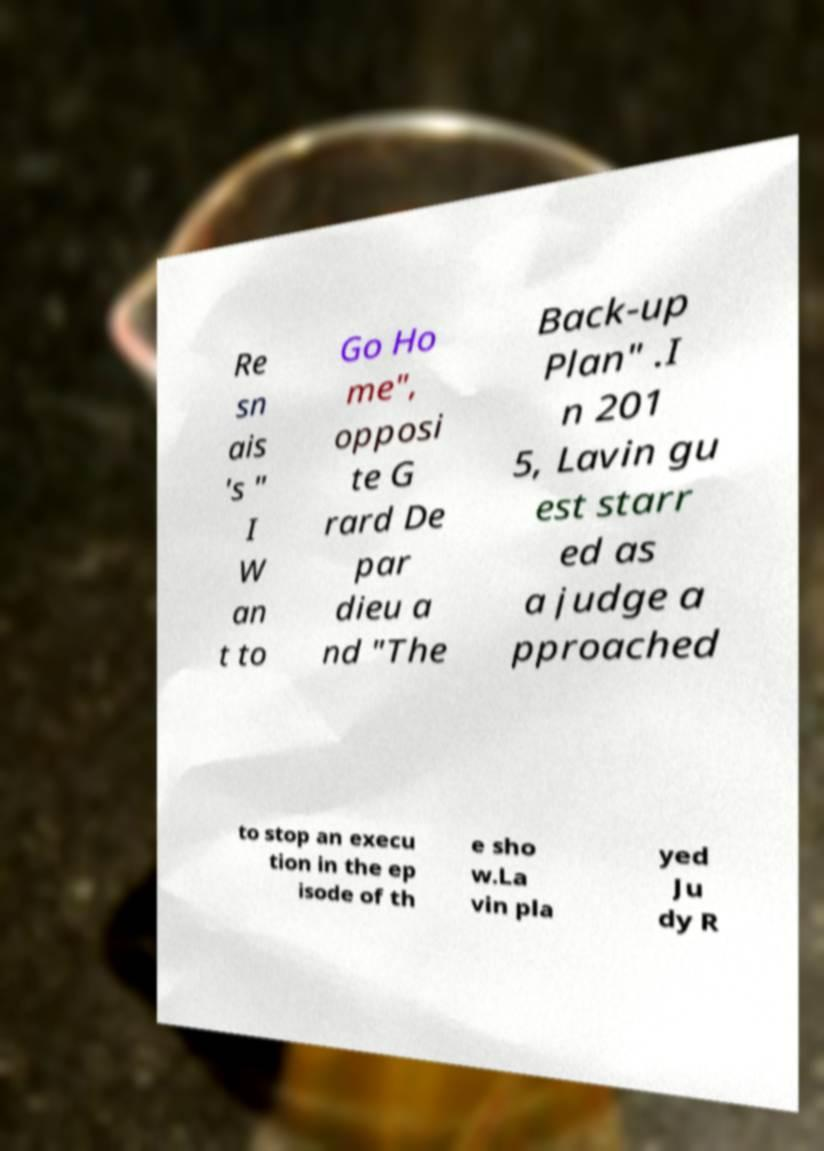What messages or text are displayed in this image? I need them in a readable, typed format. Re sn ais 's " I W an t to Go Ho me", opposi te G rard De par dieu a nd "The Back-up Plan" .I n 201 5, Lavin gu est starr ed as a judge a pproached to stop an execu tion in the ep isode of th e sho w.La vin pla yed Ju dy R 